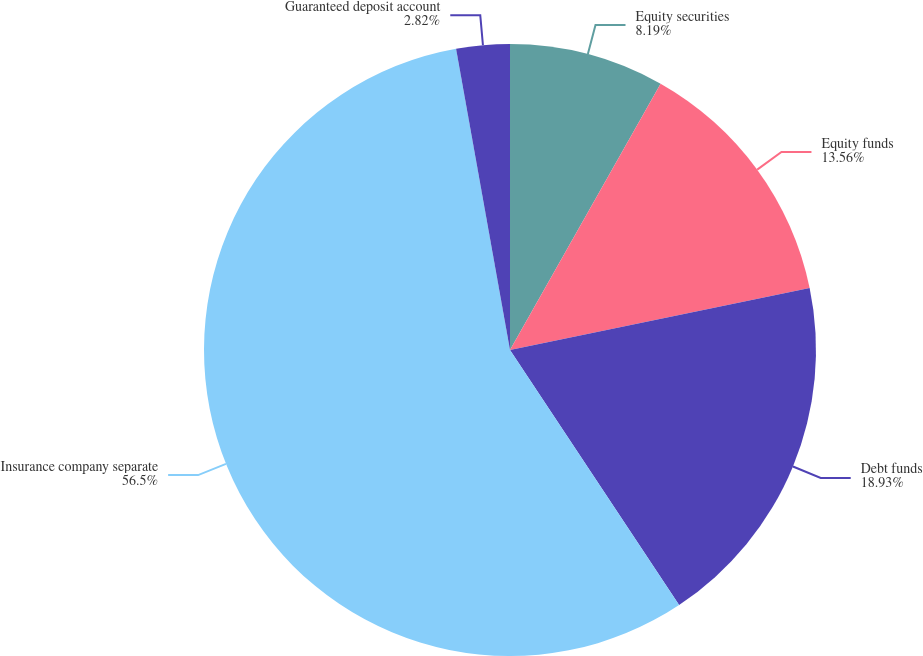Convert chart to OTSL. <chart><loc_0><loc_0><loc_500><loc_500><pie_chart><fcel>Equity securities<fcel>Equity funds<fcel>Debt funds<fcel>Insurance company separate<fcel>Guaranteed deposit account<nl><fcel>8.19%<fcel>13.56%<fcel>18.93%<fcel>56.5%<fcel>2.82%<nl></chart> 